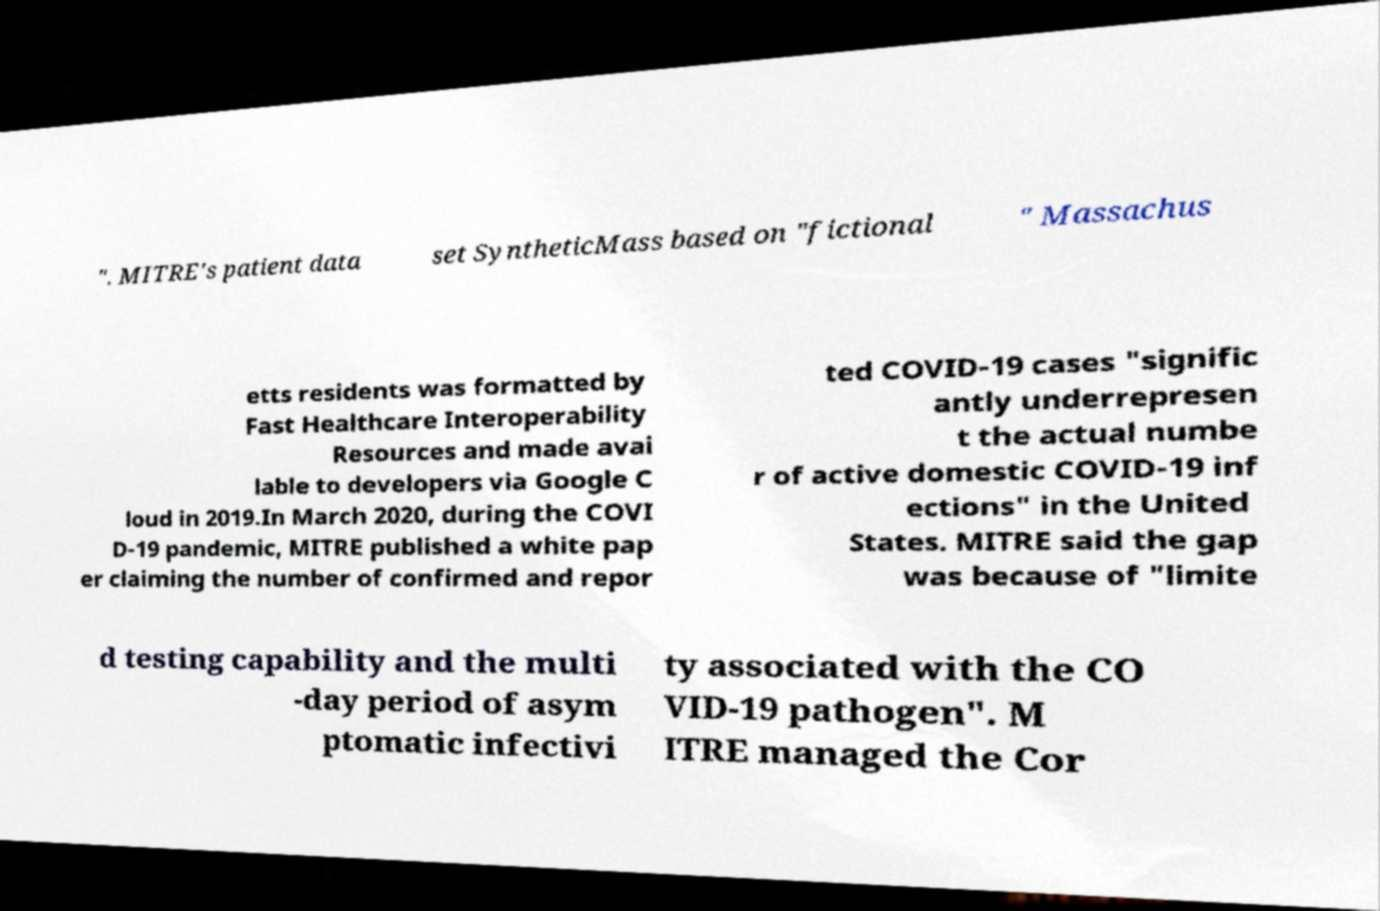For documentation purposes, I need the text within this image transcribed. Could you provide that? ". MITRE's patient data set SyntheticMass based on "fictional " Massachus etts residents was formatted by Fast Healthcare Interoperability Resources and made avai lable to developers via Google C loud in 2019.In March 2020, during the COVI D-19 pandemic, MITRE published a white pap er claiming the number of confirmed and repor ted COVID-19 cases "signific antly underrepresen t the actual numbe r of active domestic COVID-19 inf ections" in the United States. MITRE said the gap was because of "limite d testing capability and the multi -day period of asym ptomatic infectivi ty associated with the CO VID-19 pathogen". M ITRE managed the Cor 